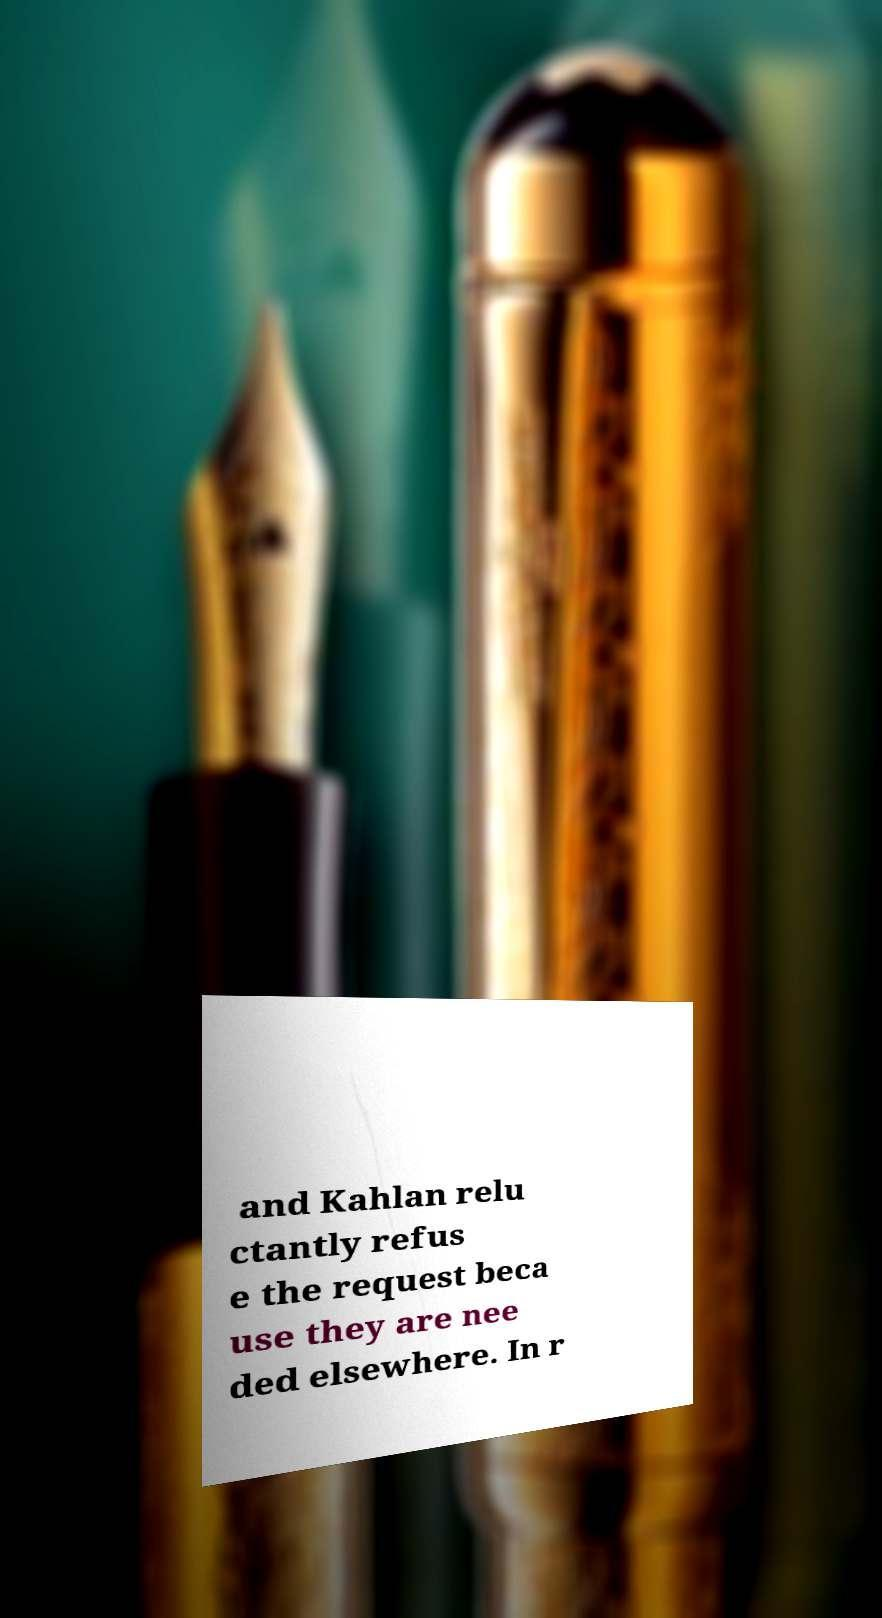What messages or text are displayed in this image? I need them in a readable, typed format. and Kahlan relu ctantly refus e the request beca use they are nee ded elsewhere. In r 